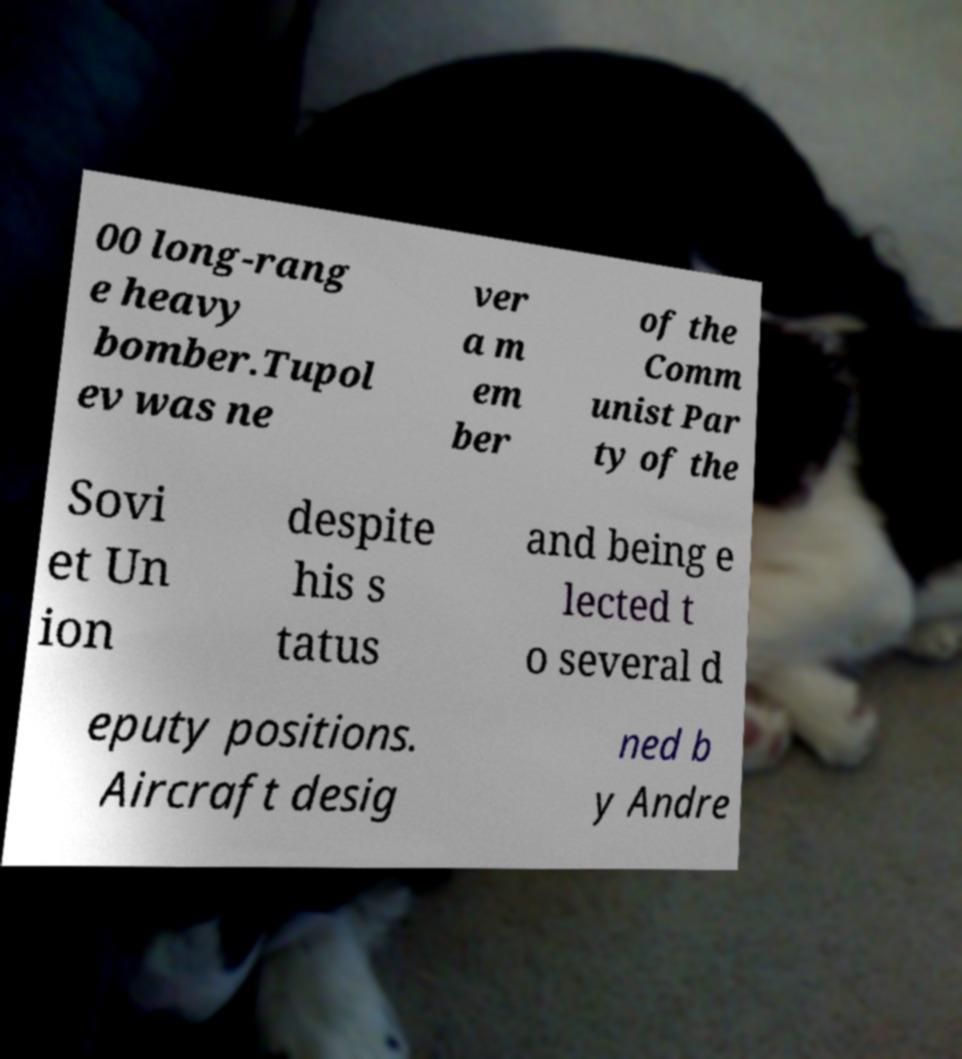What messages or text are displayed in this image? I need them in a readable, typed format. 00 long-rang e heavy bomber.Tupol ev was ne ver a m em ber of the Comm unist Par ty of the Sovi et Un ion despite his s tatus and being e lected t o several d eputy positions. Aircraft desig ned b y Andre 